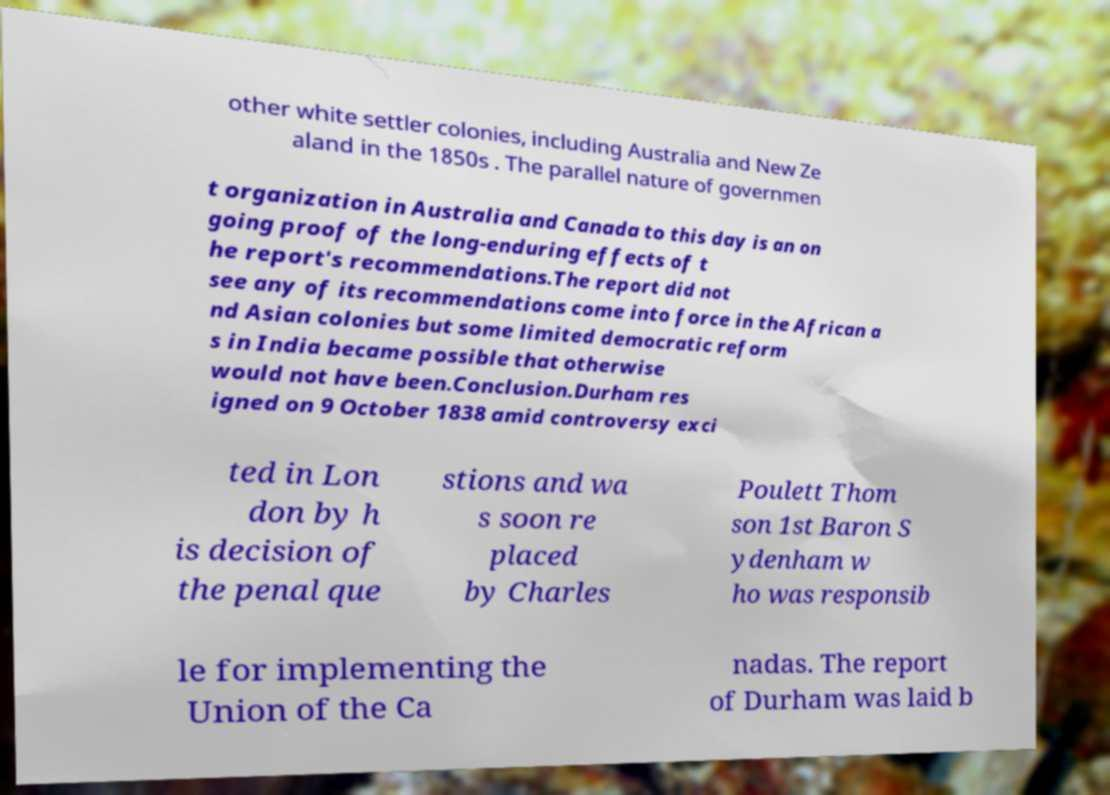For documentation purposes, I need the text within this image transcribed. Could you provide that? other white settler colonies, including Australia and New Ze aland in the 1850s . The parallel nature of governmen t organization in Australia and Canada to this day is an on going proof of the long-enduring effects of t he report's recommendations.The report did not see any of its recommendations come into force in the African a nd Asian colonies but some limited democratic reform s in India became possible that otherwise would not have been.Conclusion.Durham res igned on 9 October 1838 amid controversy exci ted in Lon don by h is decision of the penal que stions and wa s soon re placed by Charles Poulett Thom son 1st Baron S ydenham w ho was responsib le for implementing the Union of the Ca nadas. The report of Durham was laid b 